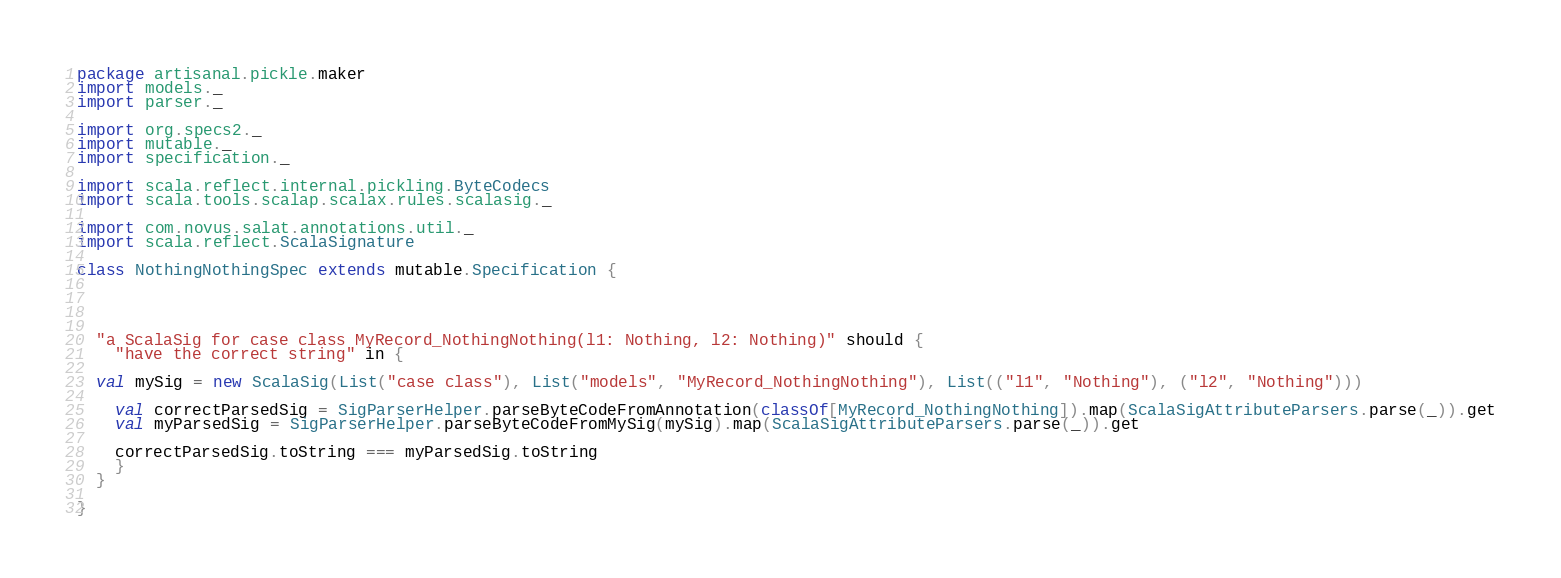Convert code to text. <code><loc_0><loc_0><loc_500><loc_500><_Scala_>package artisanal.pickle.maker 
import models._
import parser._

import org.specs2._
import mutable._
import specification._

import scala.reflect.internal.pickling.ByteCodecs
import scala.tools.scalap.scalax.rules.scalasig._

import com.novus.salat.annotations.util._
import scala.reflect.ScalaSignature

class NothingNothingSpec extends mutable.Specification {




  "a ScalaSig for case class MyRecord_NothingNothing(l1: Nothing, l2: Nothing)" should {
    "have the correct string" in {

  val mySig = new ScalaSig(List("case class"), List("models", "MyRecord_NothingNothing"), List(("l1", "Nothing"), ("l2", "Nothing")))

    val correctParsedSig = SigParserHelper.parseByteCodeFromAnnotation(classOf[MyRecord_NothingNothing]).map(ScalaSigAttributeParsers.parse(_)).get
    val myParsedSig = SigParserHelper.parseByteCodeFromMySig(mySig).map(ScalaSigAttributeParsers.parse(_)).get
 
    correctParsedSig.toString === myParsedSig.toString
    }
  }

}
</code> 